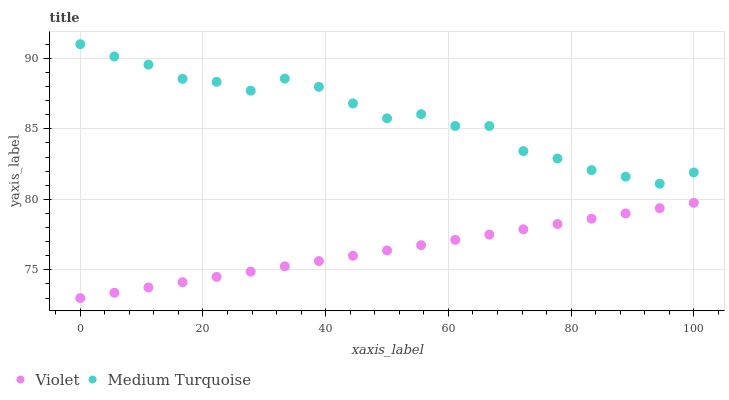Does Violet have the minimum area under the curve?
Answer yes or no. Yes. Does Medium Turquoise have the maximum area under the curve?
Answer yes or no. Yes. Does Violet have the maximum area under the curve?
Answer yes or no. No. Is Violet the smoothest?
Answer yes or no. Yes. Is Medium Turquoise the roughest?
Answer yes or no. Yes. Is Violet the roughest?
Answer yes or no. No. Does Violet have the lowest value?
Answer yes or no. Yes. Does Medium Turquoise have the highest value?
Answer yes or no. Yes. Does Violet have the highest value?
Answer yes or no. No. Is Violet less than Medium Turquoise?
Answer yes or no. Yes. Is Medium Turquoise greater than Violet?
Answer yes or no. Yes. Does Violet intersect Medium Turquoise?
Answer yes or no. No. 